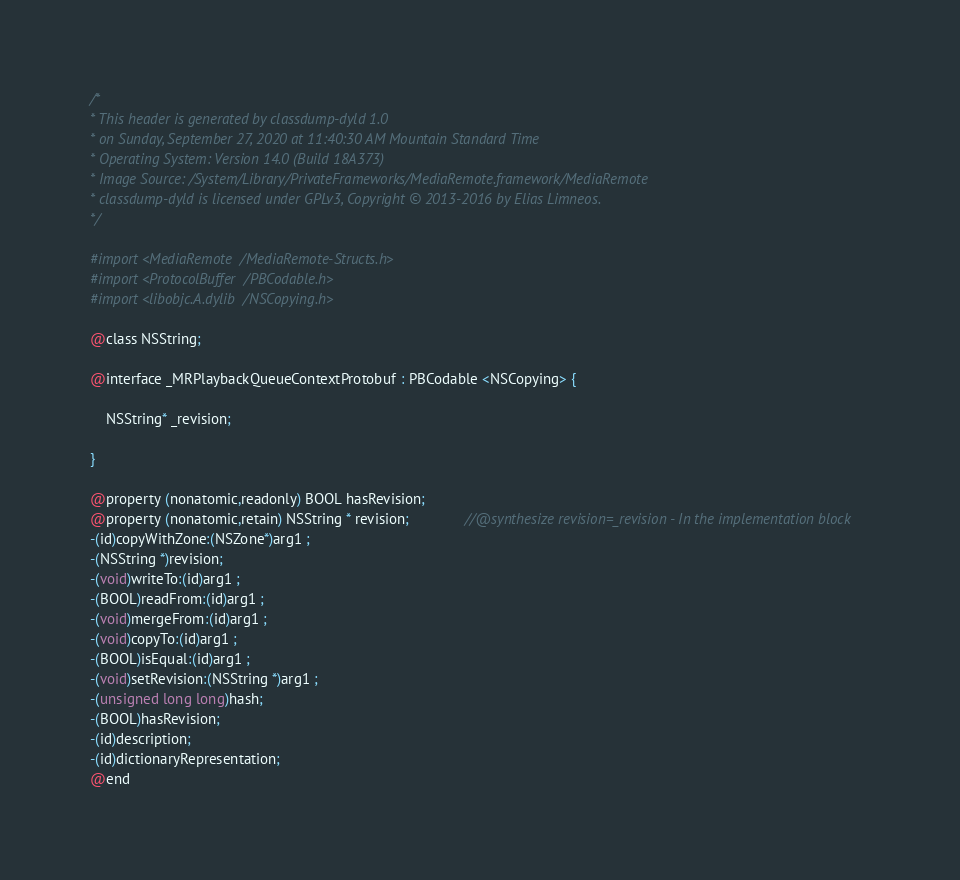Convert code to text. <code><loc_0><loc_0><loc_500><loc_500><_C_>/*
* This header is generated by classdump-dyld 1.0
* on Sunday, September 27, 2020 at 11:40:30 AM Mountain Standard Time
* Operating System: Version 14.0 (Build 18A373)
* Image Source: /System/Library/PrivateFrameworks/MediaRemote.framework/MediaRemote
* classdump-dyld is licensed under GPLv3, Copyright © 2013-2016 by Elias Limneos.
*/

#import <MediaRemote/MediaRemote-Structs.h>
#import <ProtocolBuffer/PBCodable.h>
#import <libobjc.A.dylib/NSCopying.h>

@class NSString;

@interface _MRPlaybackQueueContextProtobuf : PBCodable <NSCopying> {

	NSString* _revision;

}

@property (nonatomic,readonly) BOOL hasRevision; 
@property (nonatomic,retain) NSString * revision;              //@synthesize revision=_revision - In the implementation block
-(id)copyWithZone:(NSZone*)arg1 ;
-(NSString *)revision;
-(void)writeTo:(id)arg1 ;
-(BOOL)readFrom:(id)arg1 ;
-(void)mergeFrom:(id)arg1 ;
-(void)copyTo:(id)arg1 ;
-(BOOL)isEqual:(id)arg1 ;
-(void)setRevision:(NSString *)arg1 ;
-(unsigned long long)hash;
-(BOOL)hasRevision;
-(id)description;
-(id)dictionaryRepresentation;
@end

</code> 